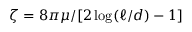<formula> <loc_0><loc_0><loc_500><loc_500>\zeta = 8 \pi \mu / [ 2 \log ( \ell / d ) - 1 ]</formula> 